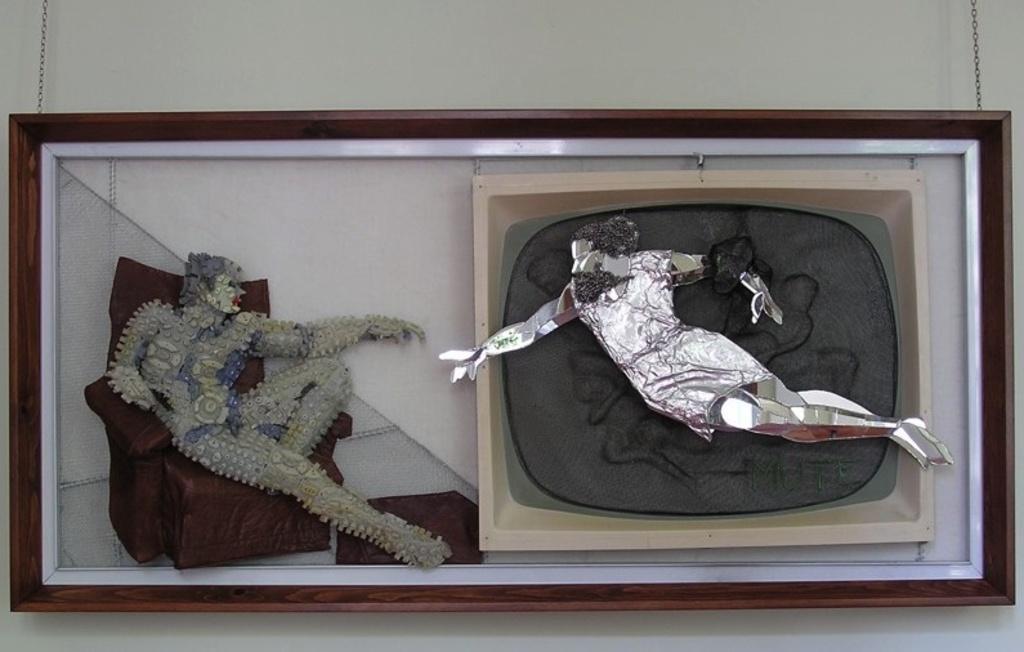Please provide a concise description of this image. In this image there is a wall for that wall there is an art, in that art there is sofa and two persons. 